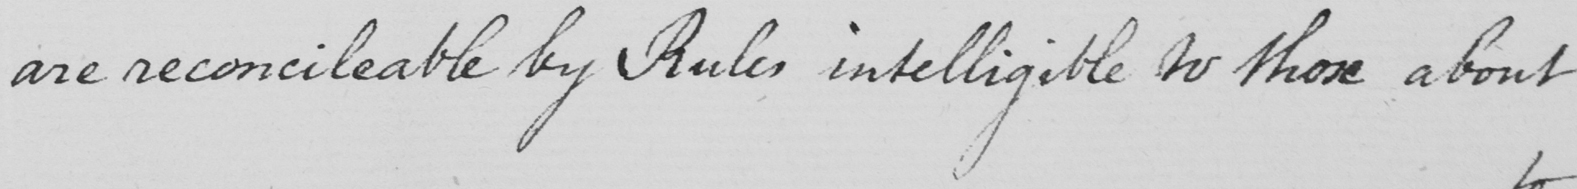What is written in this line of handwriting? are reconcileable by Rules intelligible to those about 